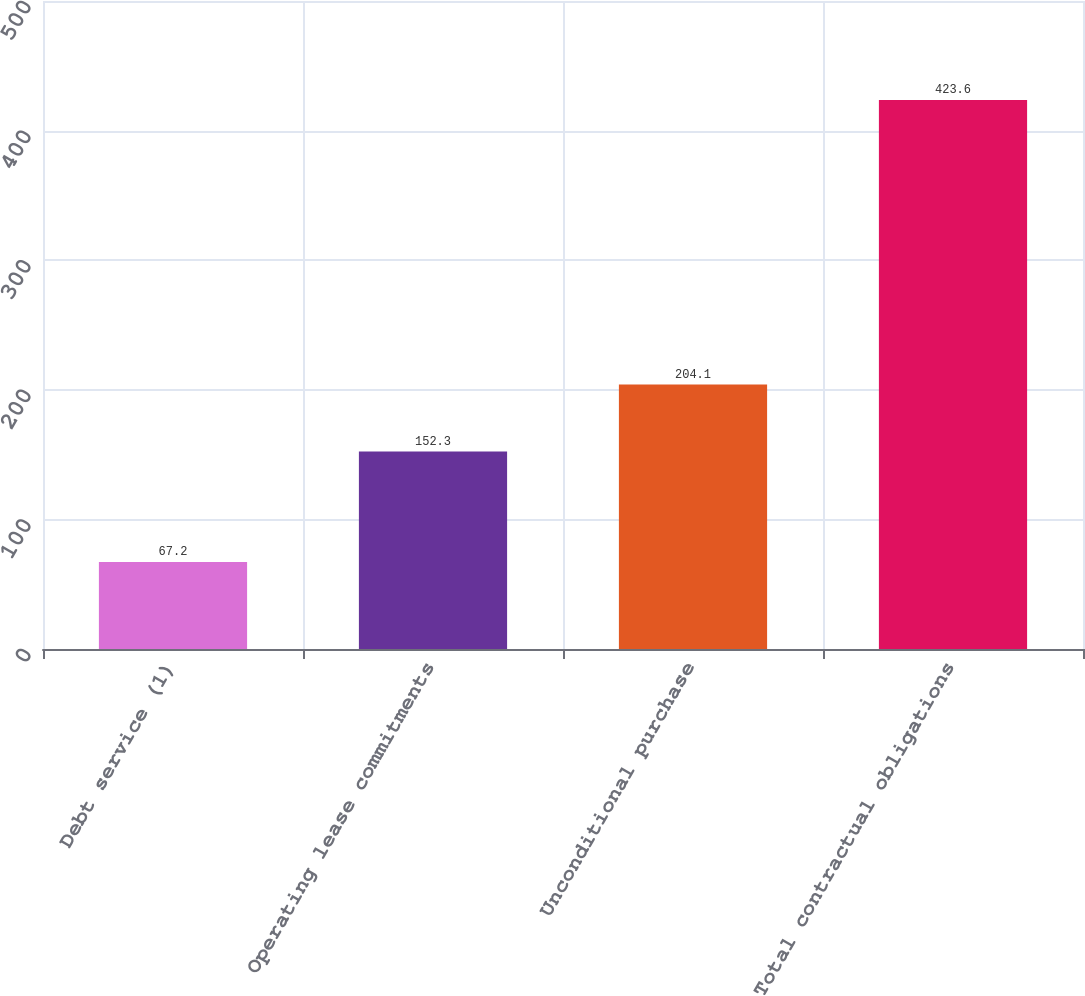Convert chart to OTSL. <chart><loc_0><loc_0><loc_500><loc_500><bar_chart><fcel>Debt service (1)<fcel>Operating lease commitments<fcel>Unconditional purchase<fcel>Total contractual obligations<nl><fcel>67.2<fcel>152.3<fcel>204.1<fcel>423.6<nl></chart> 